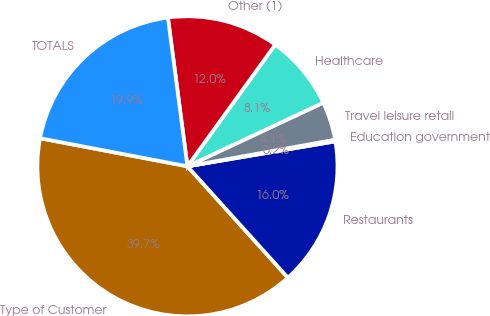<chart> <loc_0><loc_0><loc_500><loc_500><pie_chart><fcel>Type of Customer<fcel>Restaurants<fcel>Education government<fcel>Travel leisure retail<fcel>Healthcare<fcel>Other (1)<fcel>TOTALS<nl><fcel>39.68%<fcel>15.98%<fcel>0.18%<fcel>4.13%<fcel>8.08%<fcel>12.03%<fcel>19.93%<nl></chart> 